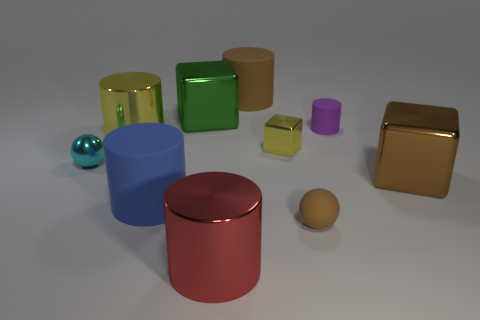Is the color of the cube in front of the small metal ball the same as the large matte cylinder behind the large blue matte cylinder?
Your answer should be very brief. Yes. There is a matte object that is the same size as the blue rubber cylinder; what is its color?
Your answer should be compact. Brown. Are there an equal number of big things left of the brown ball and yellow cylinders in front of the small metal cube?
Provide a succinct answer. No. What material is the cylinder right of the brown ball to the right of the large green metallic object made of?
Provide a short and direct response. Rubber. How many things are either tiny rubber spheres or green things?
Your answer should be very brief. 2. The cylinder that is the same color as the tiny metallic block is what size?
Provide a short and direct response. Large. Is the number of brown rubber cylinders less than the number of gray objects?
Your answer should be very brief. No. What size is the brown ball that is the same material as the purple object?
Make the answer very short. Small. How big is the green object?
Make the answer very short. Large. The small cyan metal thing is what shape?
Make the answer very short. Sphere. 